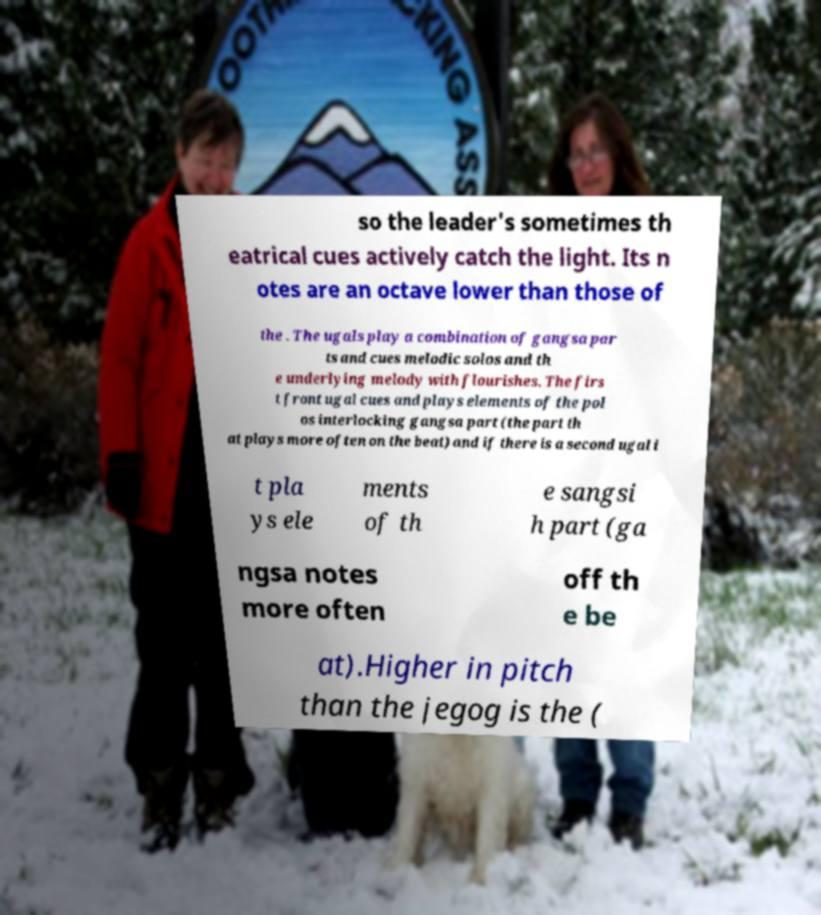Please read and relay the text visible in this image. What does it say? so the leader's sometimes th eatrical cues actively catch the light. Its n otes are an octave lower than those of the . The ugals play a combination of gangsa par ts and cues melodic solos and th e underlying melody with flourishes. The firs t front ugal cues and plays elements of the pol os interlocking gangsa part (the part th at plays more often on the beat) and if there is a second ugal i t pla ys ele ments of th e sangsi h part (ga ngsa notes more often off th e be at).Higher in pitch than the jegog is the ( 